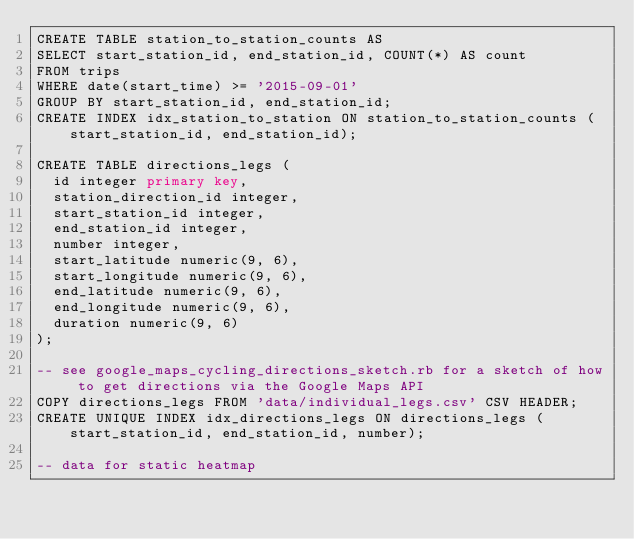Convert code to text. <code><loc_0><loc_0><loc_500><loc_500><_SQL_>CREATE TABLE station_to_station_counts AS
SELECT start_station_id, end_station_id, COUNT(*) AS count
FROM trips
WHERE date(start_time) >= '2015-09-01'
GROUP BY start_station_id, end_station_id;
CREATE INDEX idx_station_to_station ON station_to_station_counts (start_station_id, end_station_id);

CREATE TABLE directions_legs (
  id integer primary key,
  station_direction_id integer,
  start_station_id integer,
  end_station_id integer,
  number integer,
  start_latitude numeric(9, 6),
  start_longitude numeric(9, 6),
  end_latitude numeric(9, 6),
  end_longitude numeric(9, 6),
  duration numeric(9, 6)
);

-- see google_maps_cycling_directions_sketch.rb for a sketch of how to get directions via the Google Maps API
COPY directions_legs FROM 'data/individual_legs.csv' CSV HEADER;
CREATE UNIQUE INDEX idx_directions_legs ON directions_legs (start_station_id, end_station_id, number);

-- data for static heatmap</code> 